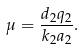Convert formula to latex. <formula><loc_0><loc_0><loc_500><loc_500>\mu = \frac { d _ { 2 } q _ { 2 } } { k _ { 2 } a _ { 2 } } .</formula> 